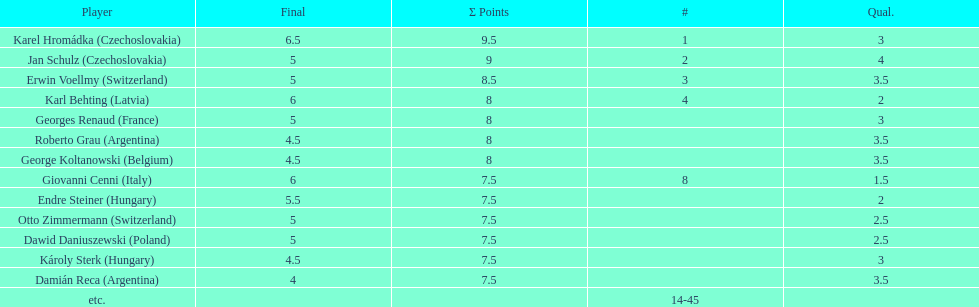Karl behting and giovanni cenni each had final scores of what? 6. 